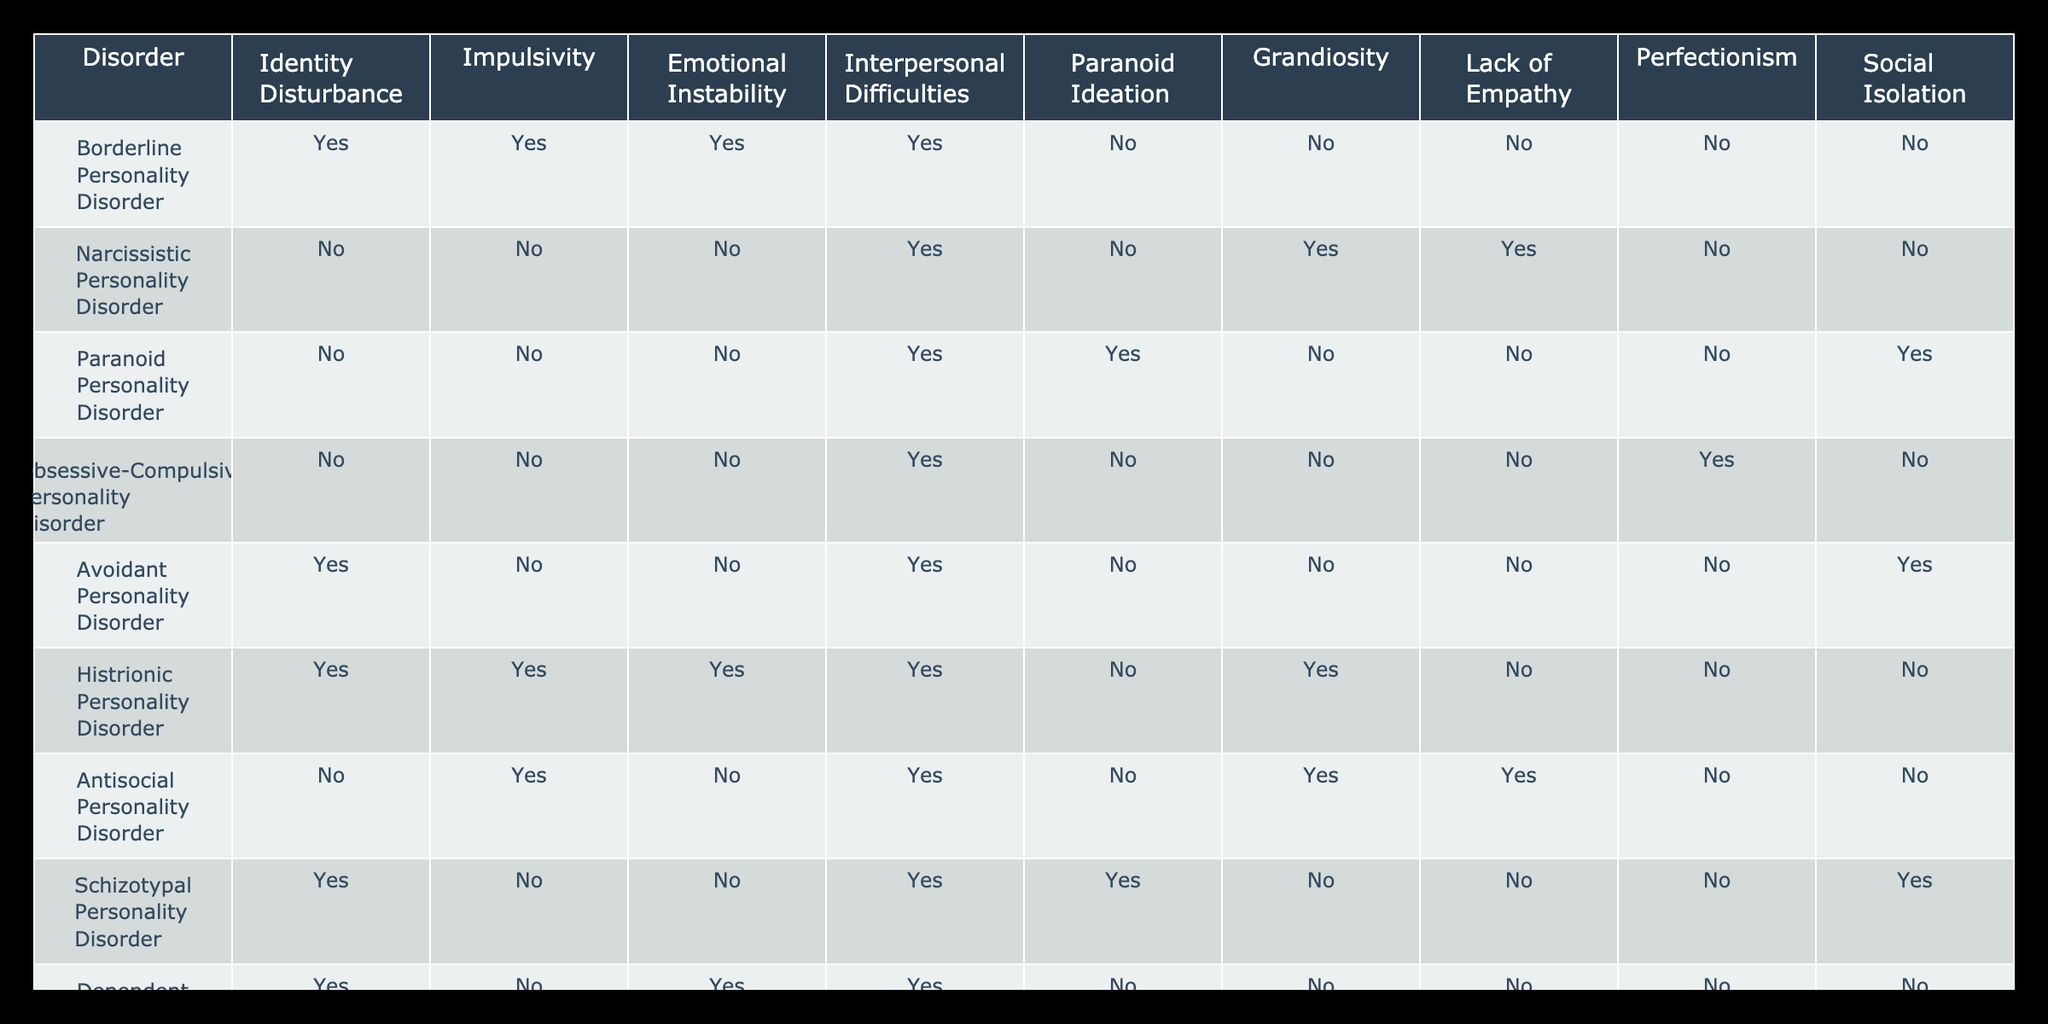What personality disorder has both emotional instability and impulsivity? The table indicates that Borderline Personality Disorder has both "Yes" in the Emotional Instability and Impulsivity columns, making it the only disorder that meets this criterion.
Answer: Borderline Personality Disorder Is there a personality disorder with grandiosity but no lack of empathy? The table shows Narcissistic Personality Disorder has "Yes" for grandiosity but "No" for lack of empathy, confirming that it meets this requirement.
Answer: Yes, Narcissistic Personality Disorder How many personality disorders exhibit social isolation? By reviewing the Social Isolation column, we can see that Avoidant Personality Disorder, Schizoid Personality Disorder, and Schizotypal Personality Disorder all have "Yes," totaling three disorders.
Answer: 3 Does Histrionic Personality Disorder include identity disturbance? According to the table, Histrionic Personality Disorder shows "Yes" for the Identity Disturbance column, verifying that it does include this characteristic.
Answer: Yes Which personality disorder has both interpersonal difficulties and perfectionism? A review of the table reveals that Obsessive-Compulsive Personality Disorder has "Yes" for interpersonal difficulties and perfectionism, indicating it meets both criteria.
Answer: Obsessive-Compulsive Personality Disorder What percentage of the listed personality disorders show impulsivity? There are 10 total disorders in the table, and 4 of them show "Yes" for impulsivity (Borderline, Histrionic, Antisocial, and Narcissistic), so the percentage is calculated as (4/10) * 100 = 40%.
Answer: 40% Which personality disorder has no indicators of emotional instability and lack of empathy? Examining the table, we can identify Paranoid Personality Disorder, which has "No" for both Emotional Instability and Lack of Empathy columns.
Answer: Paranoid Personality Disorder How many personality disorders have both paranoid ideation and social isolation? By analyzing the table, only Schizotypal Personality Disorder shows "Yes" for both Paranoid Ideation and Social Isolation, confirming that there is one disorder fitting this description.
Answer: 1 